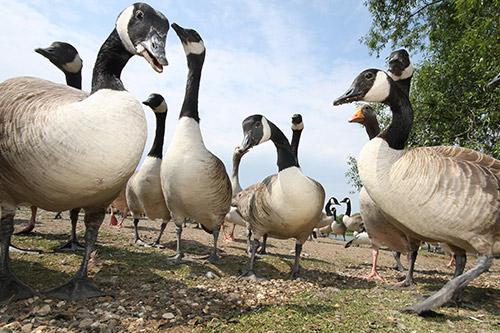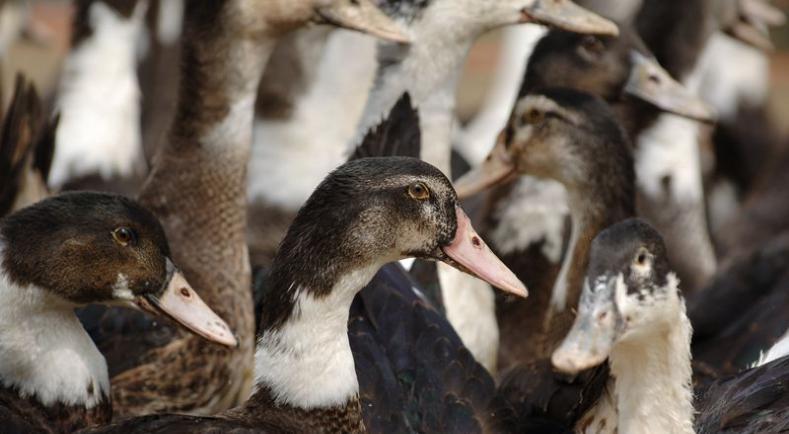The first image is the image on the left, the second image is the image on the right. Evaluate the accuracy of this statement regarding the images: "An image shows a group of water fowl all walking in the same direction.". Is it true? Answer yes or no. No. The first image is the image on the left, the second image is the image on the right. Considering the images on both sides, is "The right image shows birds standing in grass." valid? Answer yes or no. No. 